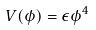Convert formula to latex. <formula><loc_0><loc_0><loc_500><loc_500>V ( \phi ) = \epsilon \phi ^ { 4 }</formula> 